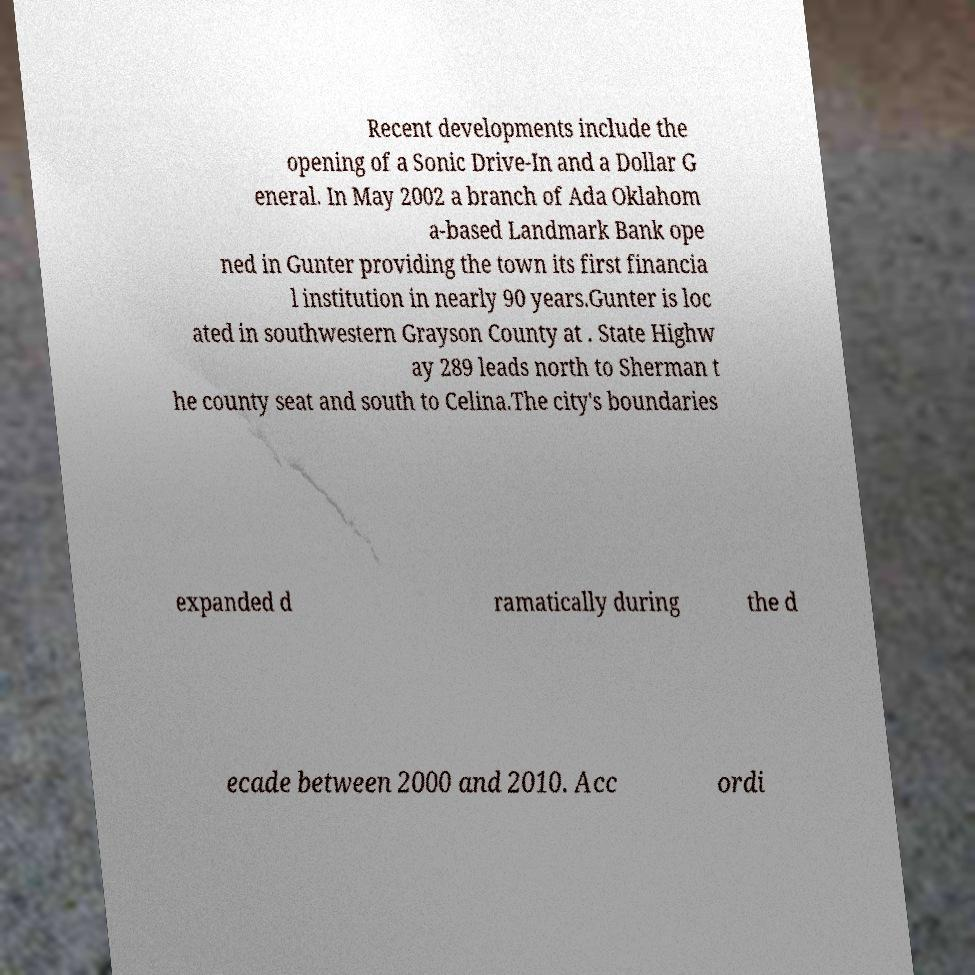For documentation purposes, I need the text within this image transcribed. Could you provide that? Recent developments include the opening of a Sonic Drive-In and a Dollar G eneral. In May 2002 a branch of Ada Oklahom a-based Landmark Bank ope ned in Gunter providing the town its first financia l institution in nearly 90 years.Gunter is loc ated in southwestern Grayson County at . State Highw ay 289 leads north to Sherman t he county seat and south to Celina.The city's boundaries expanded d ramatically during the d ecade between 2000 and 2010. Acc ordi 